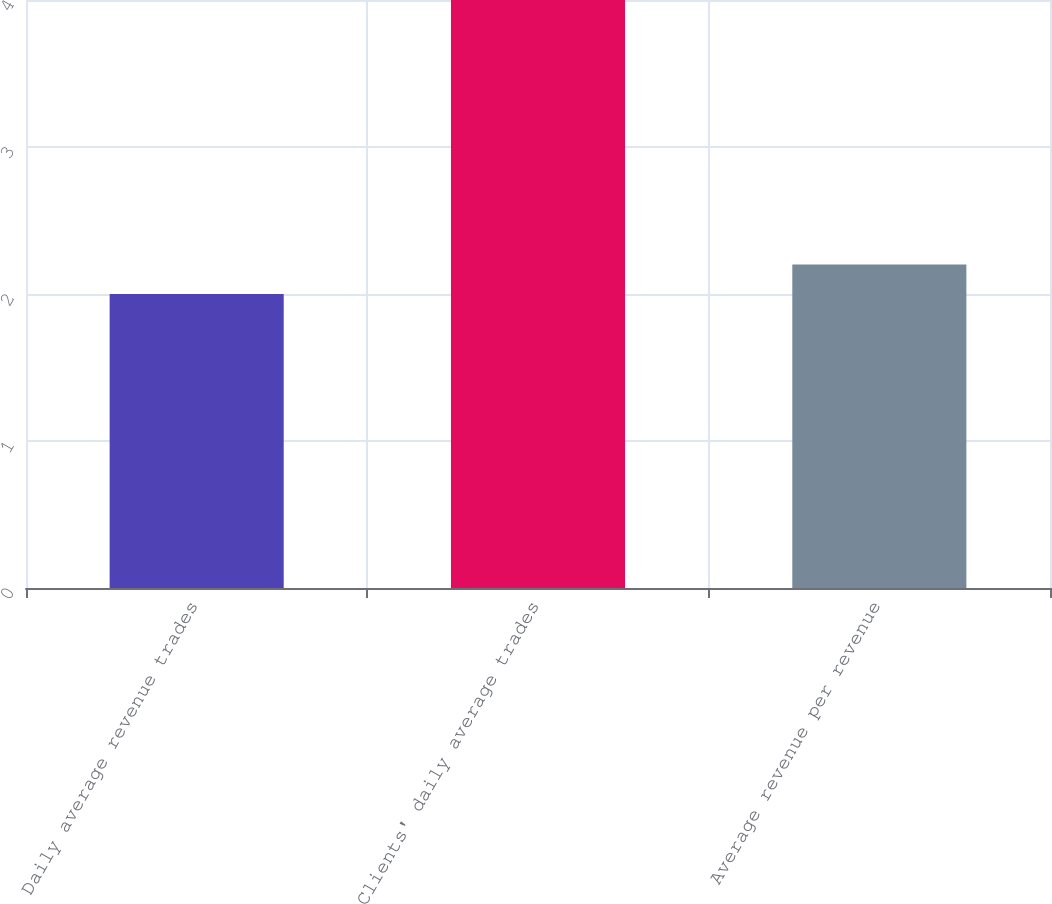<chart> <loc_0><loc_0><loc_500><loc_500><bar_chart><fcel>Daily average revenue trades<fcel>Clients' daily average trades<fcel>Average revenue per revenue<nl><fcel>2<fcel>4<fcel>2.2<nl></chart> 